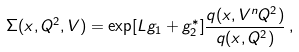Convert formula to latex. <formula><loc_0><loc_0><loc_500><loc_500>\Sigma ( x , Q ^ { 2 } , V ) = \exp [ L g _ { 1 } + g _ { 2 } ^ { * } ] \frac { q ( x , V ^ { n } Q ^ { 2 } ) } { q ( x , Q ^ { 2 } ) } \, ,</formula> 